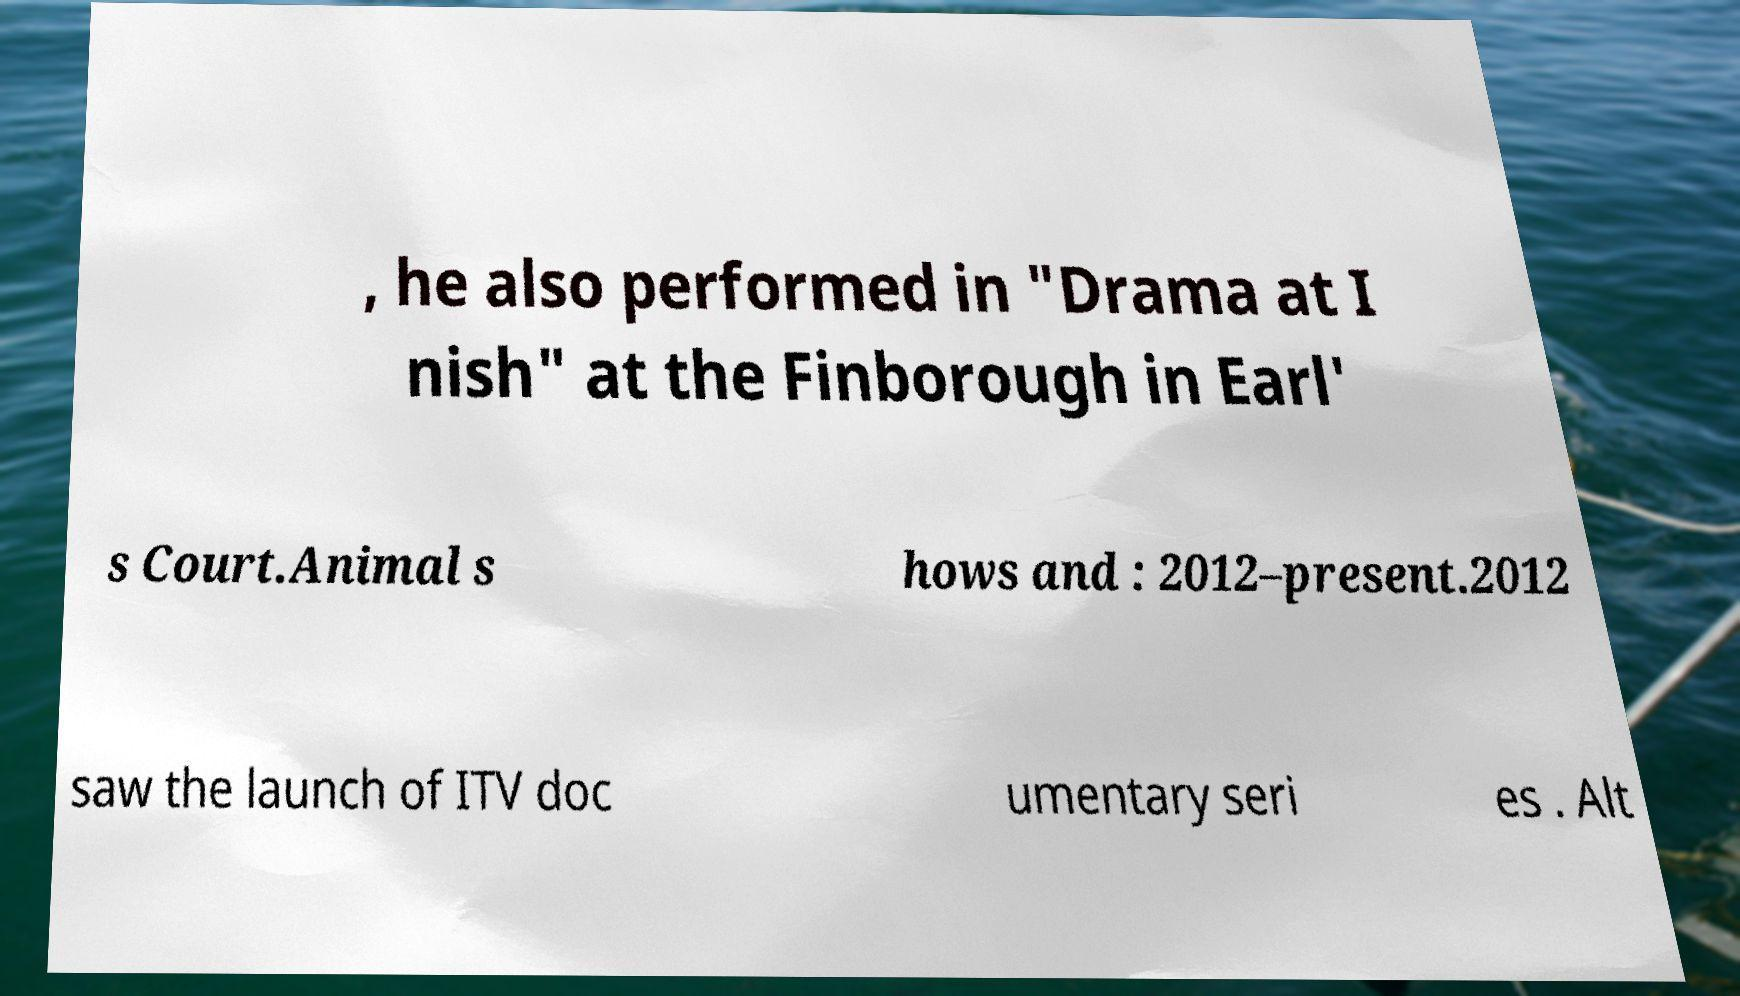For documentation purposes, I need the text within this image transcribed. Could you provide that? , he also performed in "Drama at I nish" at the Finborough in Earl' s Court.Animal s hows and : 2012–present.2012 saw the launch of ITV doc umentary seri es . Alt 